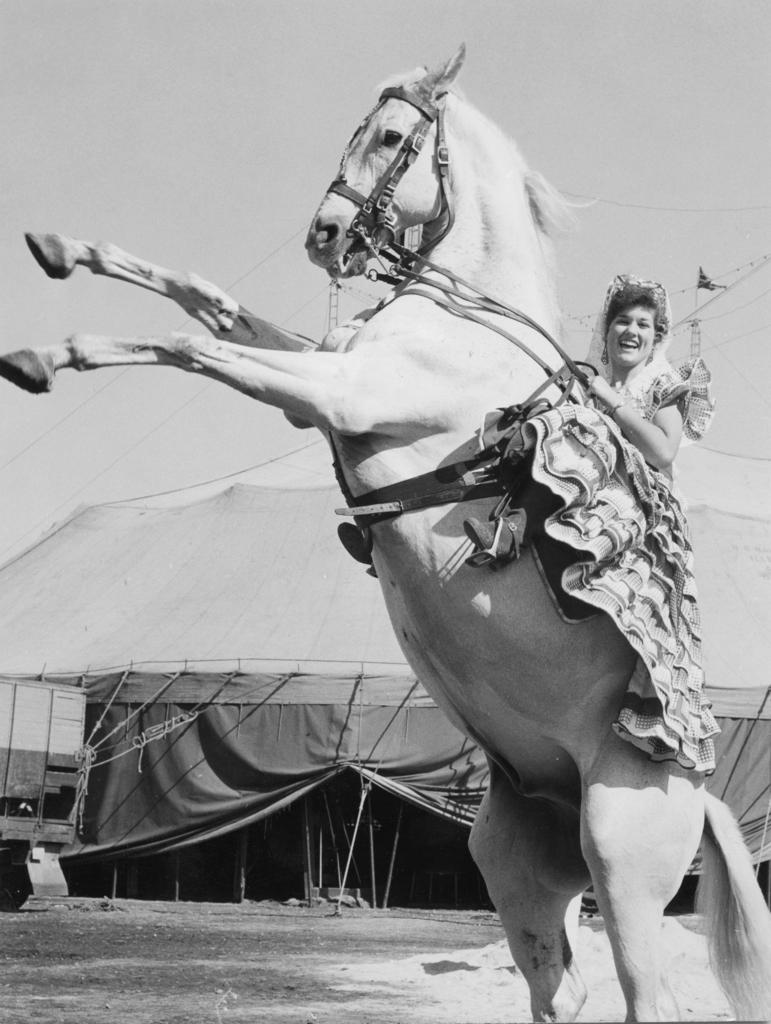Who is the main subject in the image? There is a woman in the image. What is the woman doing in the image? The woman is laughing. What is the woman sitting on in the image? The woman is sitting on a horse. What can be seen in the background of the image? There is sky visible in the image. What type of shelter is present in the image? There is a tent in the image. What type of branch is the woman holding in the image? There is no branch present in the image. What authority does the woman have in the image? The image does not depict any authority or power dynamics; it simply shows a woman laughing while sitting on a horse. 